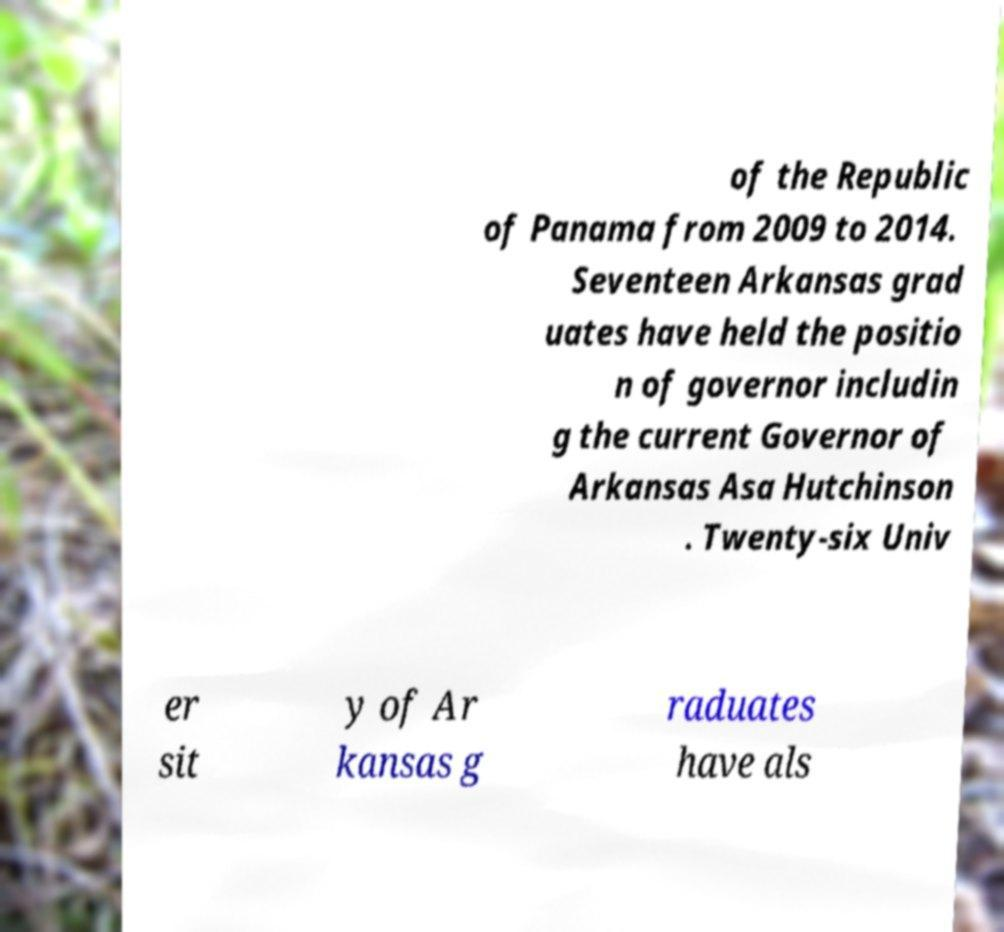Please identify and transcribe the text found in this image. of the Republic of Panama from 2009 to 2014. Seventeen Arkansas grad uates have held the positio n of governor includin g the current Governor of Arkansas Asa Hutchinson . Twenty-six Univ er sit y of Ar kansas g raduates have als 